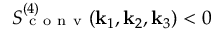<formula> <loc_0><loc_0><loc_500><loc_500>S _ { c o n v } ^ { ( 4 ) } ( k _ { 1 } , k _ { 2 } , k _ { 3 } ) < 0</formula> 